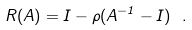<formula> <loc_0><loc_0><loc_500><loc_500>R ( A ) = I - \rho ( A ^ { - 1 } - I ) \ .</formula> 